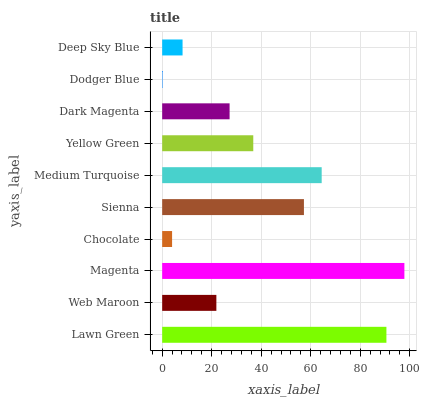Is Dodger Blue the minimum?
Answer yes or no. Yes. Is Magenta the maximum?
Answer yes or no. Yes. Is Web Maroon the minimum?
Answer yes or no. No. Is Web Maroon the maximum?
Answer yes or no. No. Is Lawn Green greater than Web Maroon?
Answer yes or no. Yes. Is Web Maroon less than Lawn Green?
Answer yes or no. Yes. Is Web Maroon greater than Lawn Green?
Answer yes or no. No. Is Lawn Green less than Web Maroon?
Answer yes or no. No. Is Yellow Green the high median?
Answer yes or no. Yes. Is Dark Magenta the low median?
Answer yes or no. Yes. Is Sienna the high median?
Answer yes or no. No. Is Lawn Green the low median?
Answer yes or no. No. 